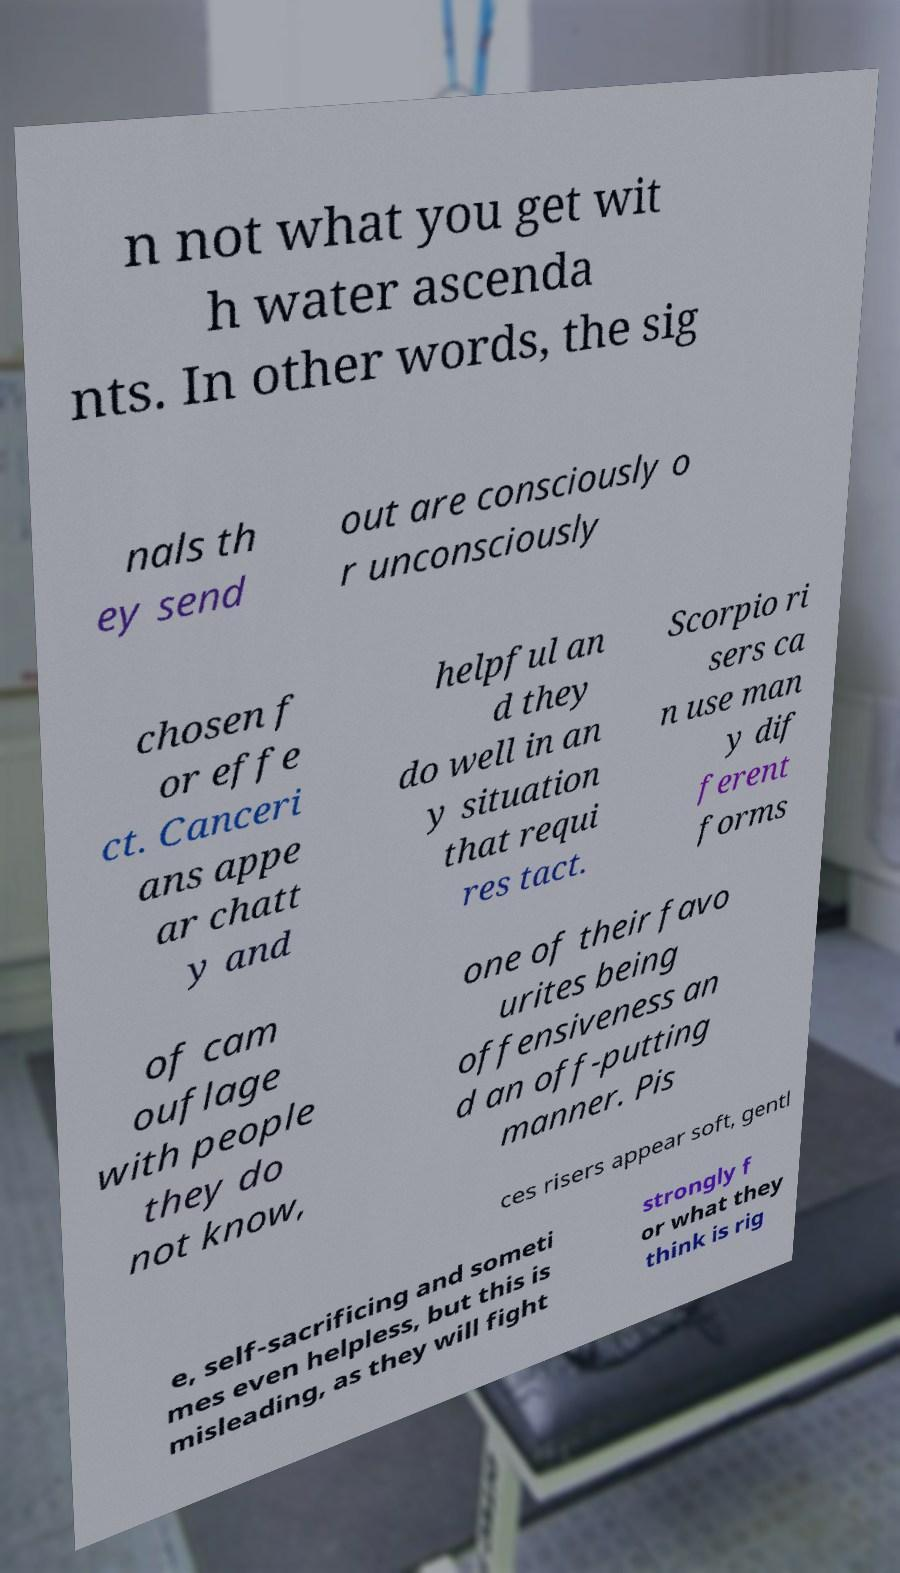Please identify and transcribe the text found in this image. n not what you get wit h water ascenda nts. In other words, the sig nals th ey send out are consciously o r unconsciously chosen f or effe ct. Canceri ans appe ar chatt y and helpful an d they do well in an y situation that requi res tact. Scorpio ri sers ca n use man y dif ferent forms of cam ouflage with people they do not know, one of their favo urites being offensiveness an d an off-putting manner. Pis ces risers appear soft, gentl e, self-sacrificing and someti mes even helpless, but this is misleading, as they will fight strongly f or what they think is rig 